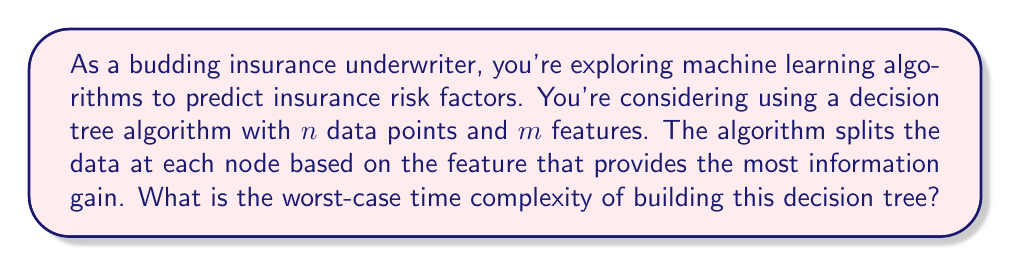Can you answer this question? To analyze the worst-case time complexity of building a decision tree for insurance risk prediction, let's break down the process:

1. At each node, we need to evaluate all features to find the best split:
   - For each feature, we need to sort the data points: $O(n \log n)$
   - We then calculate the information gain for each possible split: $O(n)$
   - This is done for all $m$ features: $O(m \cdot n \log n)$

2. In the worst case, the tree could be completely unbalanced, with a depth of $n$:
   - This means we would need to create $n$ nodes

3. Combining these factors, the worst-case time complexity is:
   $$O(n \cdot m \cdot n \log n) = O(mn^2 \log n)$$

4. This complexity can be interpreted as follows:
   - $m$: represents the number of features we're considering
   - $n^2$: for each level of the tree (potentially up to $n$ levels), we're processing $n$ data points
   - $\log n$: comes from the sorting operation at each node

5. It's worth noting that this is a pessimistic upper bound. In practice:
   - The tree depth is often limited to control overfitting
   - Optimizations like pre-sorting or using approximate splits can improve performance

For an insurance underwriter, this complexity analysis suggests that as the number of data points ($n$) or features ($m$) increases, the time to build the model will grow significantly. This could impact the feasibility of using such models for real-time risk assessment on large datasets.
Answer: The worst-case time complexity of building the decision tree is $O(mn^2 \log n)$, where $n$ is the number of data points and $m$ is the number of features. 